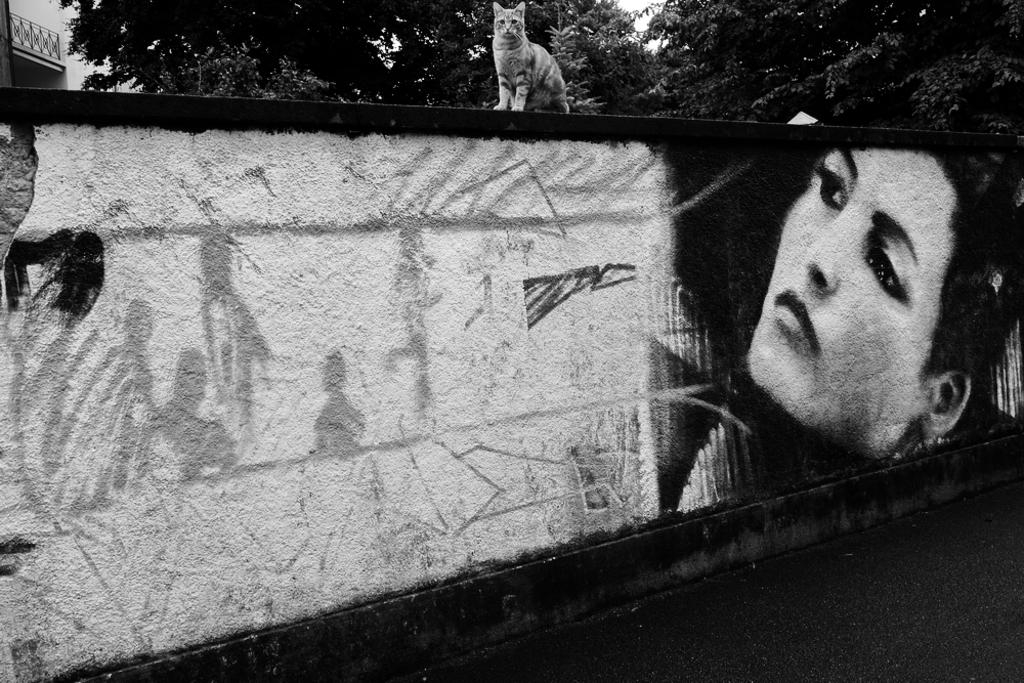What animal is on the wall in the image? There is a cat on the wall in the image. What else can be seen on the wall besides the cat? There are paintings on the wall in the image. What can be seen in the background of the image? There is a building and trees visible in the background of the image. What is the color scheme of the image? The image is in black and white. How many pigs are present in the image? There are no pigs present in the image. What class is the cat attending in the image? The image does not depict a class or any educational setting, so it is not possible to determine the cat's class. 